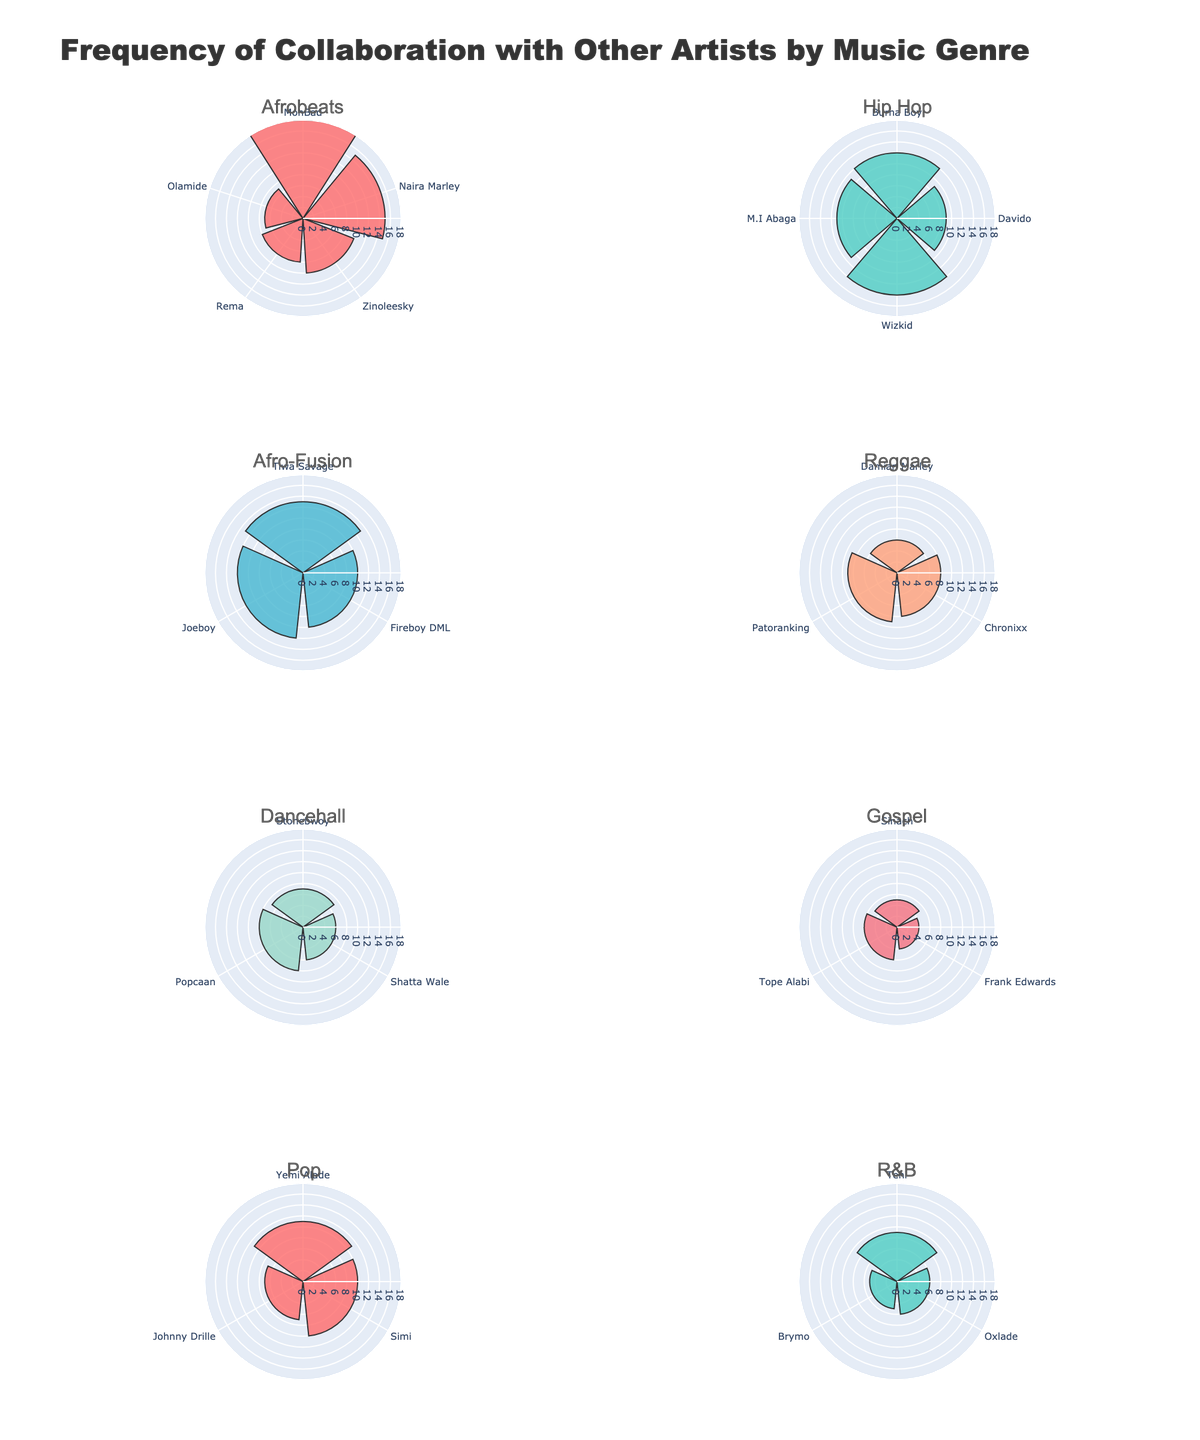Who has the highest frequency of collaboration in the Hip Hop genre? In the subplot for Hip Hop, look for the longest bar. Wizkid has the highest value at 14 collaborations.
Answer: Wizkid Which genre has the most frequent collaboration with MohBad? In the subplot for Afrobeats, the length of the bar for MohBad is the longest at 18 collaborations. So, the genre is Afrobeats.
Answer: Afrobeats What is the combined frequency of collaboration for the top two artists in the Dancehall genre? Find the two longest bars in the Dancehall subplot. Stonebwoy has 7 and Popcaan has 8 collaborations. Combined frequency is 7 + 8 = 15.
Answer: 15 Which genre shows Tiwa Savage with 13 collaborations? Locate the subplot with the artist Tiwa Savage and 13 collaborations. She appears in the Afro-Fusion genre.
Answer: Afro-Fusion How many artists are displayed in the Pop genre subplot? Count the number of bars or artists in the Pop subplot. There are 3 artists: Yemi Alade, Simi, and Johnny Drille.
Answer: 3 Who has the least frequency of collaboration in the Gospel genre? Find the shortest bar in the Gospel subplot. Frank Edwards has the lowest frequency with 4 collaborations.
Answer: Frank Edwards Which genre has the artist with the highest single frequency of collaboration, and what is that frequency? Compare the longest bars across all subplots. MohBad in Afrobeats has the longest bar with 18 collaborations, the highest in all genres.
Answer: Afrobeats, 18 What is the average frequency of collaboration for artists in the R&B genre? Find the bars in the R&B subplot. Teni has 9, Oxlade has 6, and Brymo has 5 collaborations. The sum is 9 + 6 + 5 = 20, and there are 3 artists. The average is 20 / 3 ≈ 6.67.
Answer: 6.67 Which genre has the least frequent collaboration occurrences among its artists? Compare the overall height of the bars in all subplots. Gospel has the smallest overall height with collaboration frequencies of 5, 4, and 6.
Answer: Gospel How does the frequency of collaboration of Patoranking in Reggae compare with Joeboy in Afro-Fusion? Look at both subplots for the respective artists. Patoranking has 9 collaborations, while Joeboy has 12. Patoranking has fewer collaborations than Joeboy.
Answer: Patoranking has fewer 